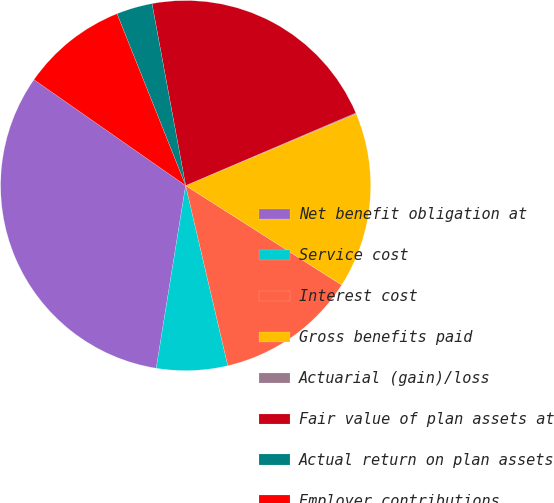Convert chart. <chart><loc_0><loc_0><loc_500><loc_500><pie_chart><fcel>Net benefit obligation at<fcel>Service cost<fcel>Interest cost<fcel>Gross benefits paid<fcel>Actuarial (gain)/loss<fcel>Fair value of plan assets at<fcel>Actual return on plan assets<fcel>Employer contributions<nl><fcel>32.16%<fcel>6.2%<fcel>12.31%<fcel>15.37%<fcel>0.08%<fcel>21.49%<fcel>3.14%<fcel>9.25%<nl></chart> 